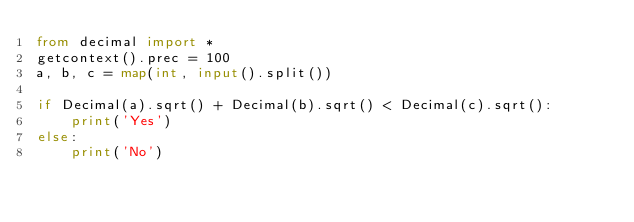<code> <loc_0><loc_0><loc_500><loc_500><_Python_>from decimal import *
getcontext().prec = 100
a, b, c = map(int, input().split())

if Decimal(a).sqrt() + Decimal(b).sqrt() < Decimal(c).sqrt():
    print('Yes')
else:
    print('No')
</code> 